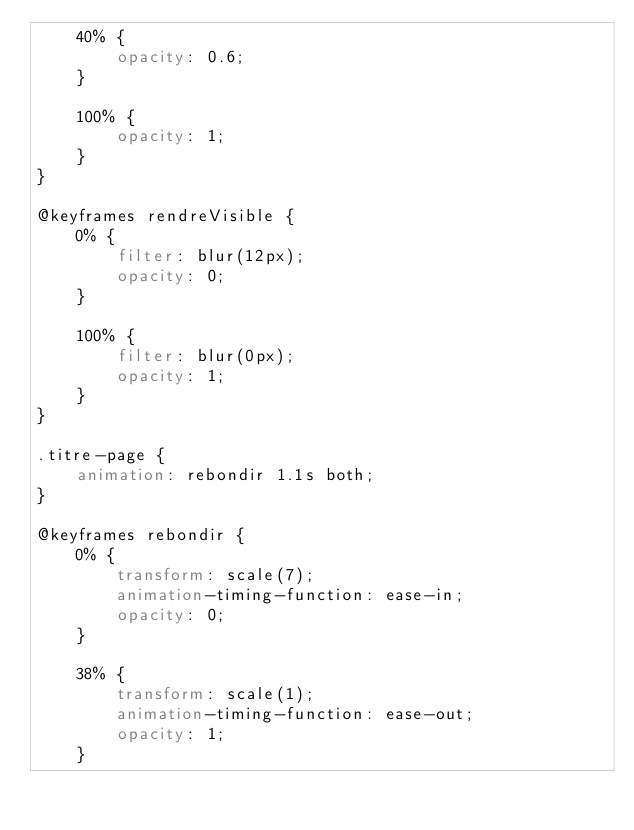<code> <loc_0><loc_0><loc_500><loc_500><_CSS_>    40% {
        opacity: 0.6;
    }

    100% {
        opacity: 1;
    }
}

@keyframes rendreVisible {
    0% {
        filter: blur(12px);
        opacity: 0;
    }

    100% {
        filter: blur(0px);
        opacity: 1;
    }
}

.titre-page {
    animation: rebondir 1.1s both;
}

@keyframes rebondir {
    0% {
        transform: scale(7);
        animation-timing-function: ease-in;
        opacity: 0;
    }

    38% {
        transform: scale(1);
        animation-timing-function: ease-out;
        opacity: 1;
    }
</code> 